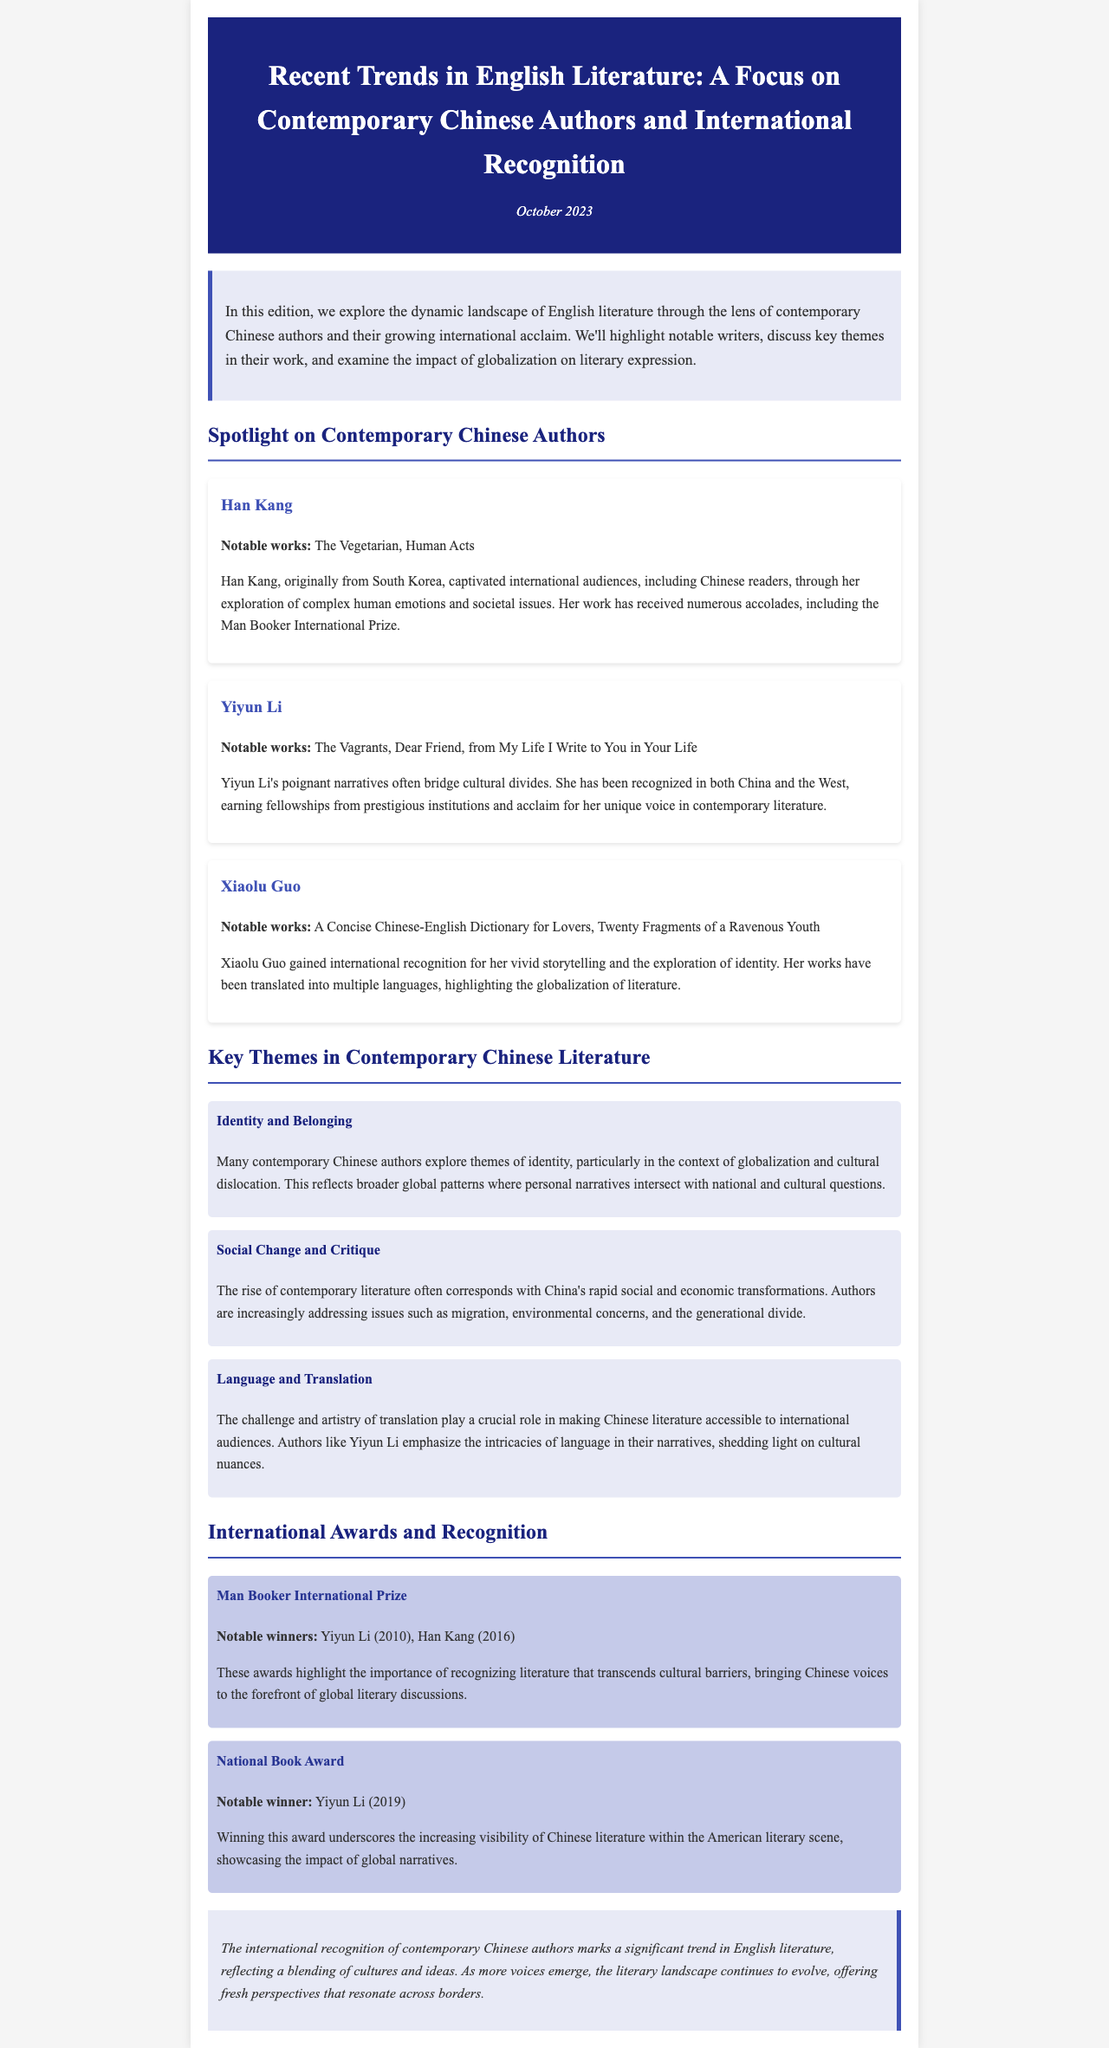What is the title of the newsletter? The title is explicitly stated at the beginning of the document as the main header.
Answer: Recent Trends in English Literature: A Focus on Contemporary Chinese Authors and International Recognition Who won the Man Booker International Prize in 2016? The document lists the winners of the Man Booker International Prize under the international awards section.
Answer: Han Kang How many notable works are credited to Yiyun Li? The number of notable works for each author is mentioned in its respective section under "Notable works."
Answer: Three What key theme addresses cultural dislocation? The themes in contemporary Chinese literature are outlined in their respective sections, with identity as a central issue under globalization.
Answer: Identity and Belonging What award did Yiyun Li win in 2019? This information is specified in the international awards section, connecting an author to a specific award.
Answer: National Book Award What do many contemporary Chinese authors explore? The specific themes are discussed in a section that highlights broader patterns in literature.
Answer: Identity Which author is known for "The Vegetarian"? Notable works listed under each author provide clarity on which author wrote specific titles.
Answer: Han Kang What is a significant trend in English literature mentioned? The conclusion highlights the development and movement of literature in context with cultural exchange.
Answer: International recognition of contemporary Chinese authors 